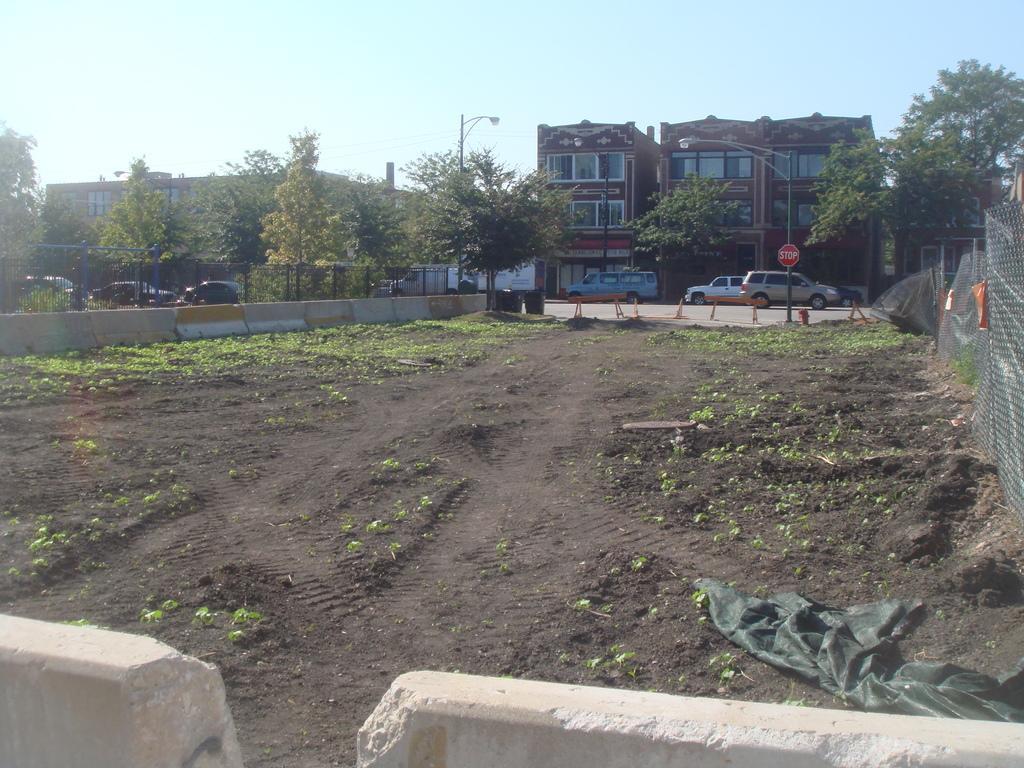In one or two sentences, can you explain what this image depicts? In this picture I can see buildings, trees and few cars parked and I can see a sign board and I can see metal fence on the right side and I can see a cloth on the ground and a pole light and I can see a blue sky. 